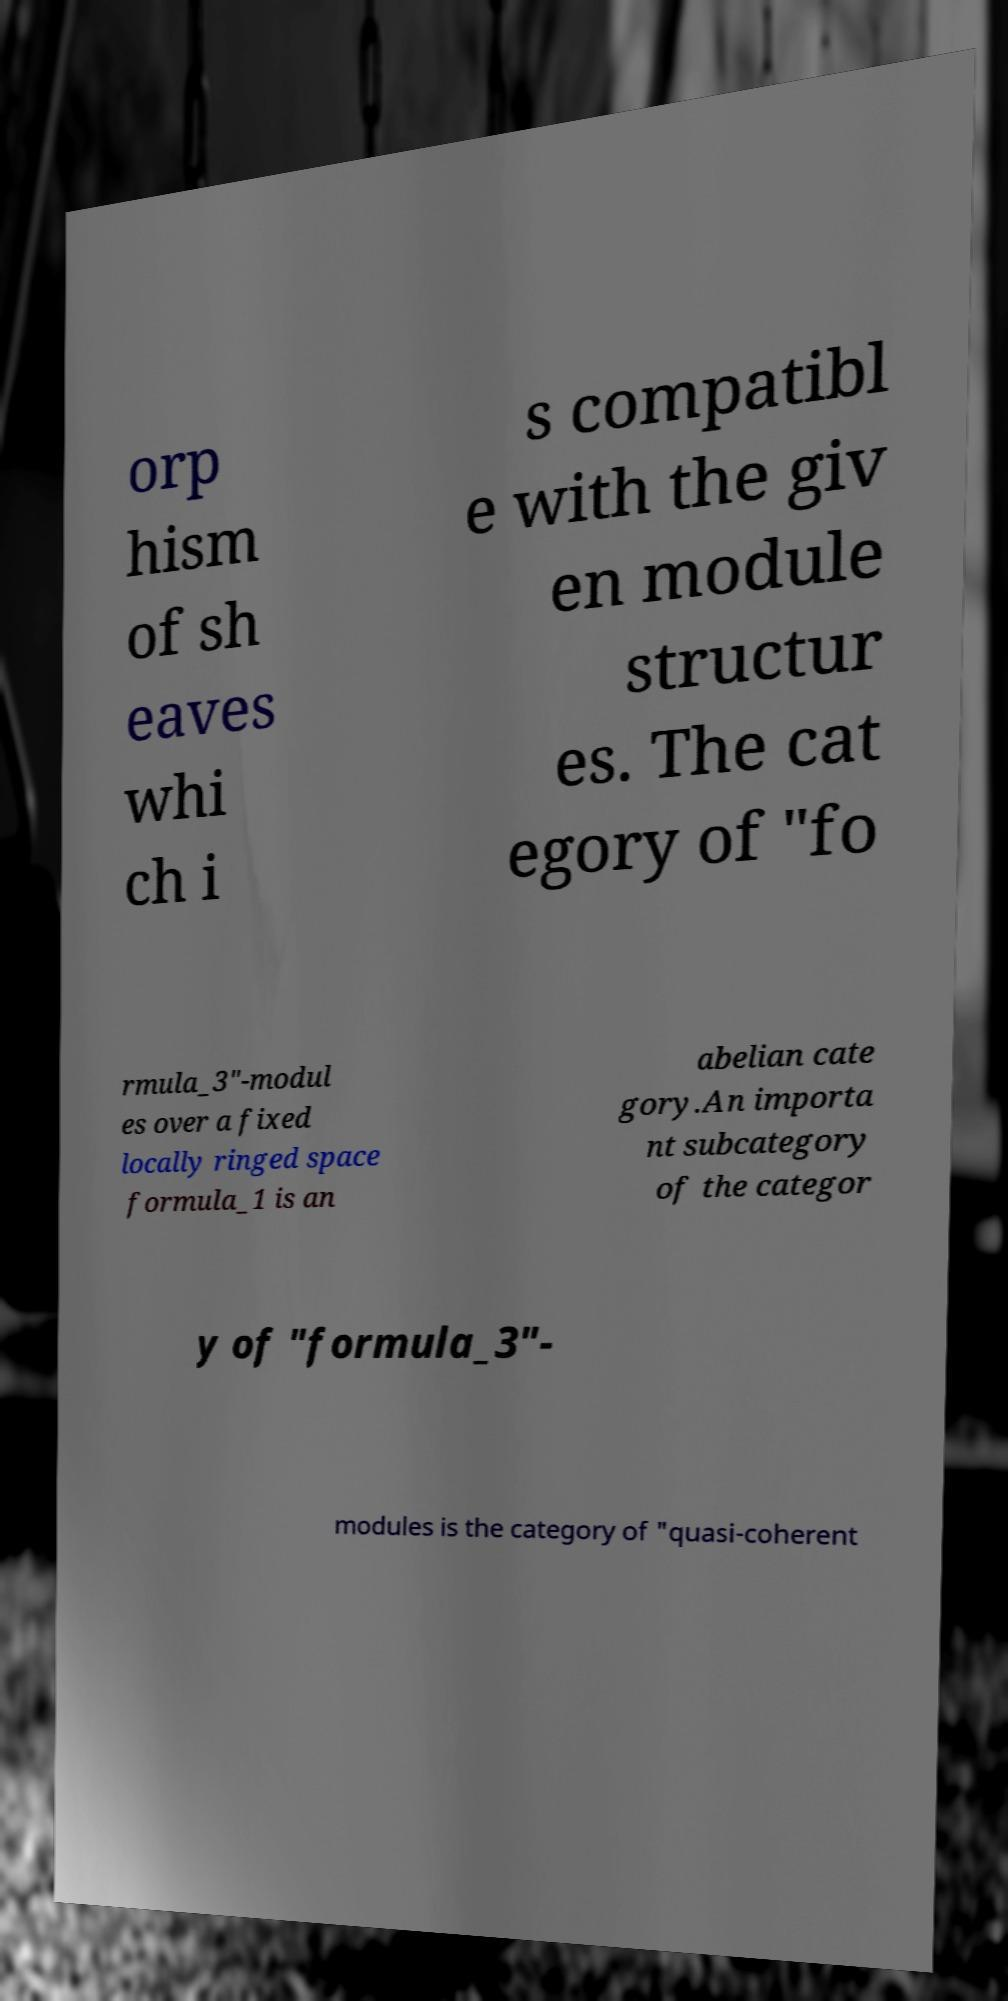Could you assist in decoding the text presented in this image and type it out clearly? orp hism of sh eaves whi ch i s compatibl e with the giv en module structur es. The cat egory of "fo rmula_3"-modul es over a fixed locally ringed space formula_1 is an abelian cate gory.An importa nt subcategory of the categor y of "formula_3"- modules is the category of "quasi-coherent 